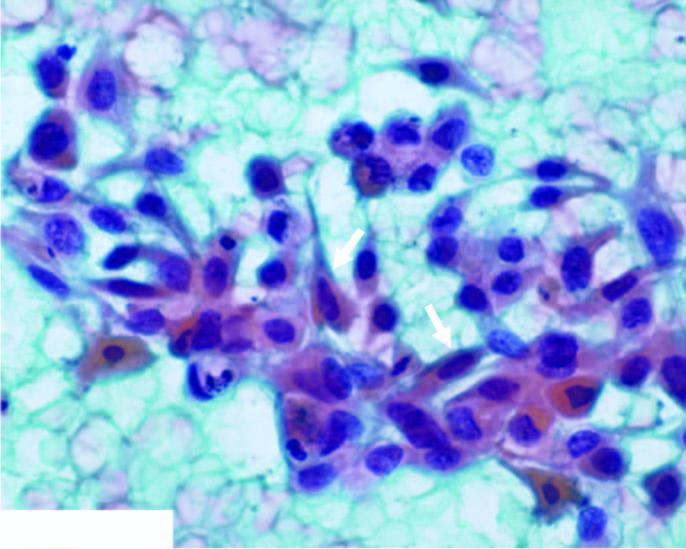how do the malignant epithelial cells have anisonucleosis?
Answer the question using a single word or phrase. With irregular nuclear chromatin with prominent nucleoli 